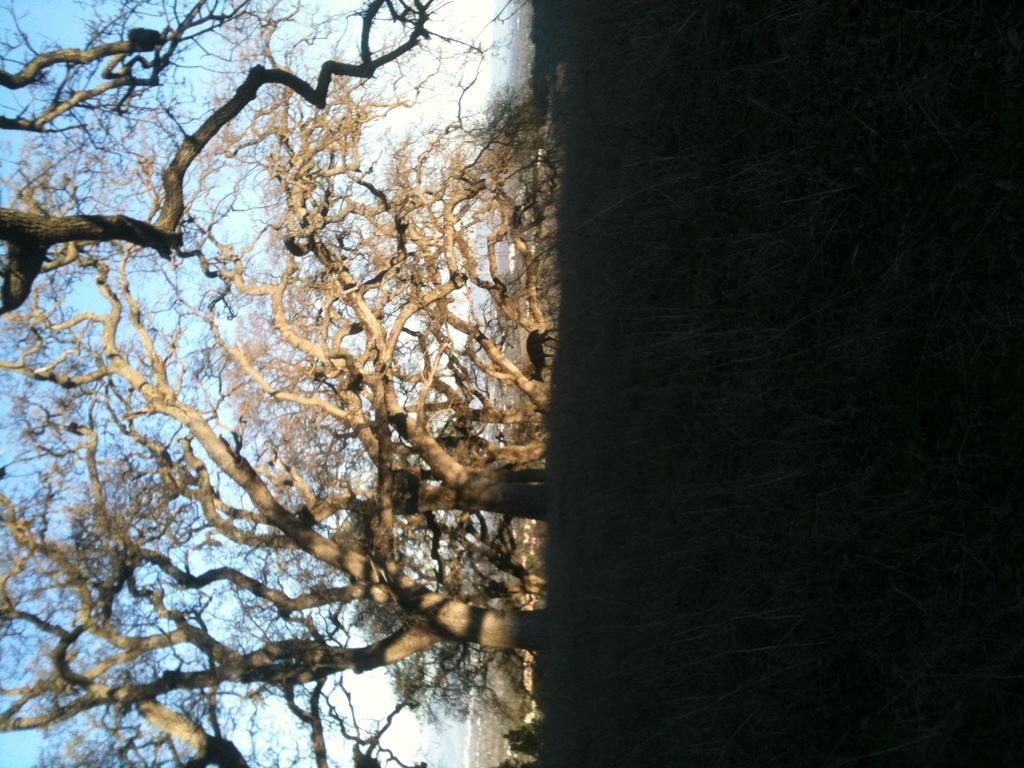What is the main subject in the center of the image? There is an animal in the center of the image. What type of vegetation can be seen on the right side of the image? There is grass on the right side of the image. What type of vegetation can be seen on the left side of the image? There are trees on the left side of the image. What is visible in the background of the image? The sky is visible in the background of the image. How many ants can be seen crawling on the leaf in the image? There is no leaf or ants present in the image. What type of ocean can be seen in the background of the image? There is no ocean present in the image; only the sky is visible in the background. 